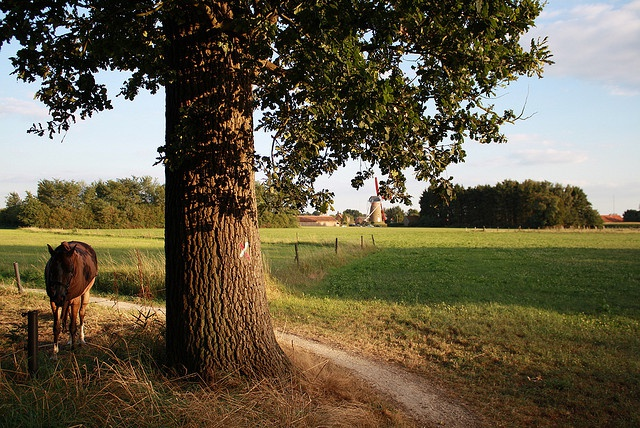Describe the objects in this image and their specific colors. I can see a horse in lightblue, black, maroon, and brown tones in this image. 